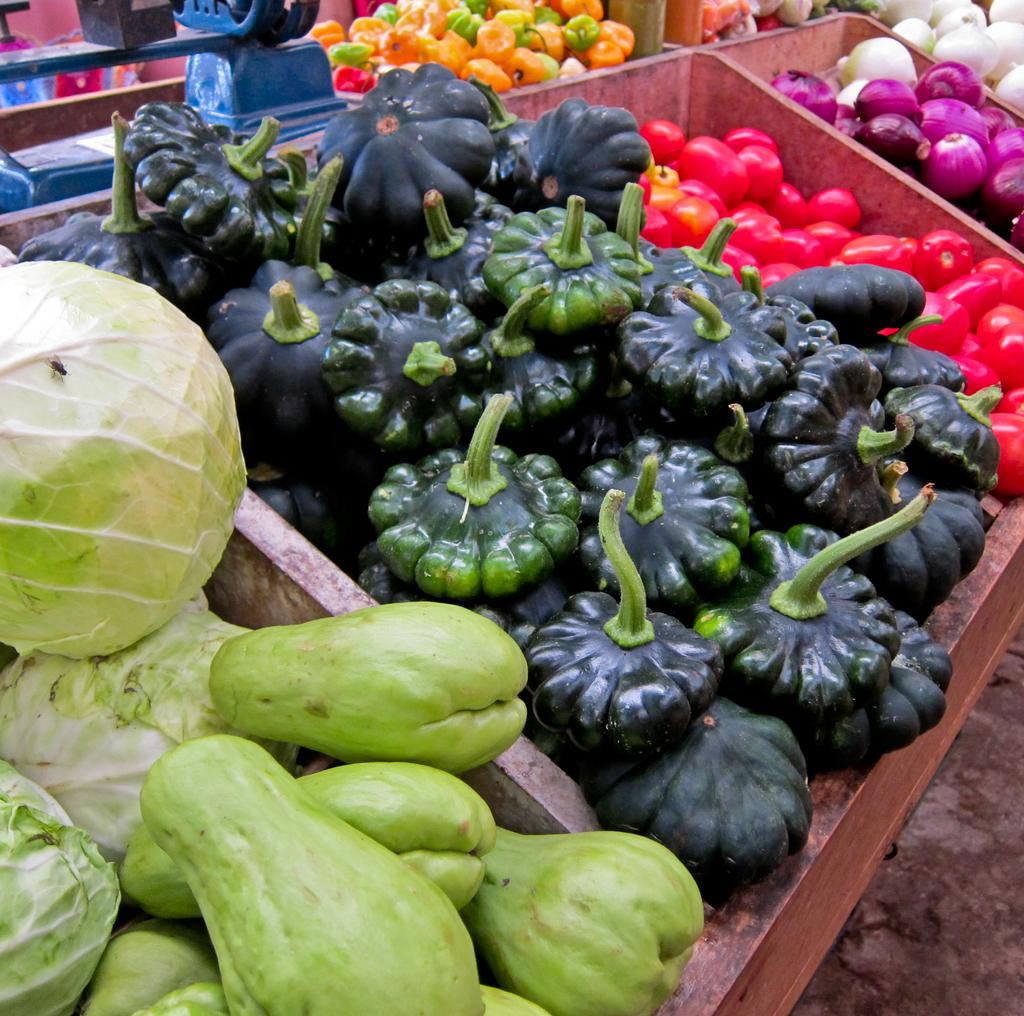What type of food items are present in the image? There are vegetables in the image. Can you name the specific vegetables that can be seen? The vegetables include cabbage, capsicum, tomatoes, and onions. Where are the vegetables located in the image? The vegetables are in boxes in the foreground of the image. What else can be seen in the background of the image? There is an object visible in the background of the image, and there are additional vegetables present. What color is the stocking that the cabbage is wearing in the image? There are no stockings or clothing items visible on the vegetables in the image. 